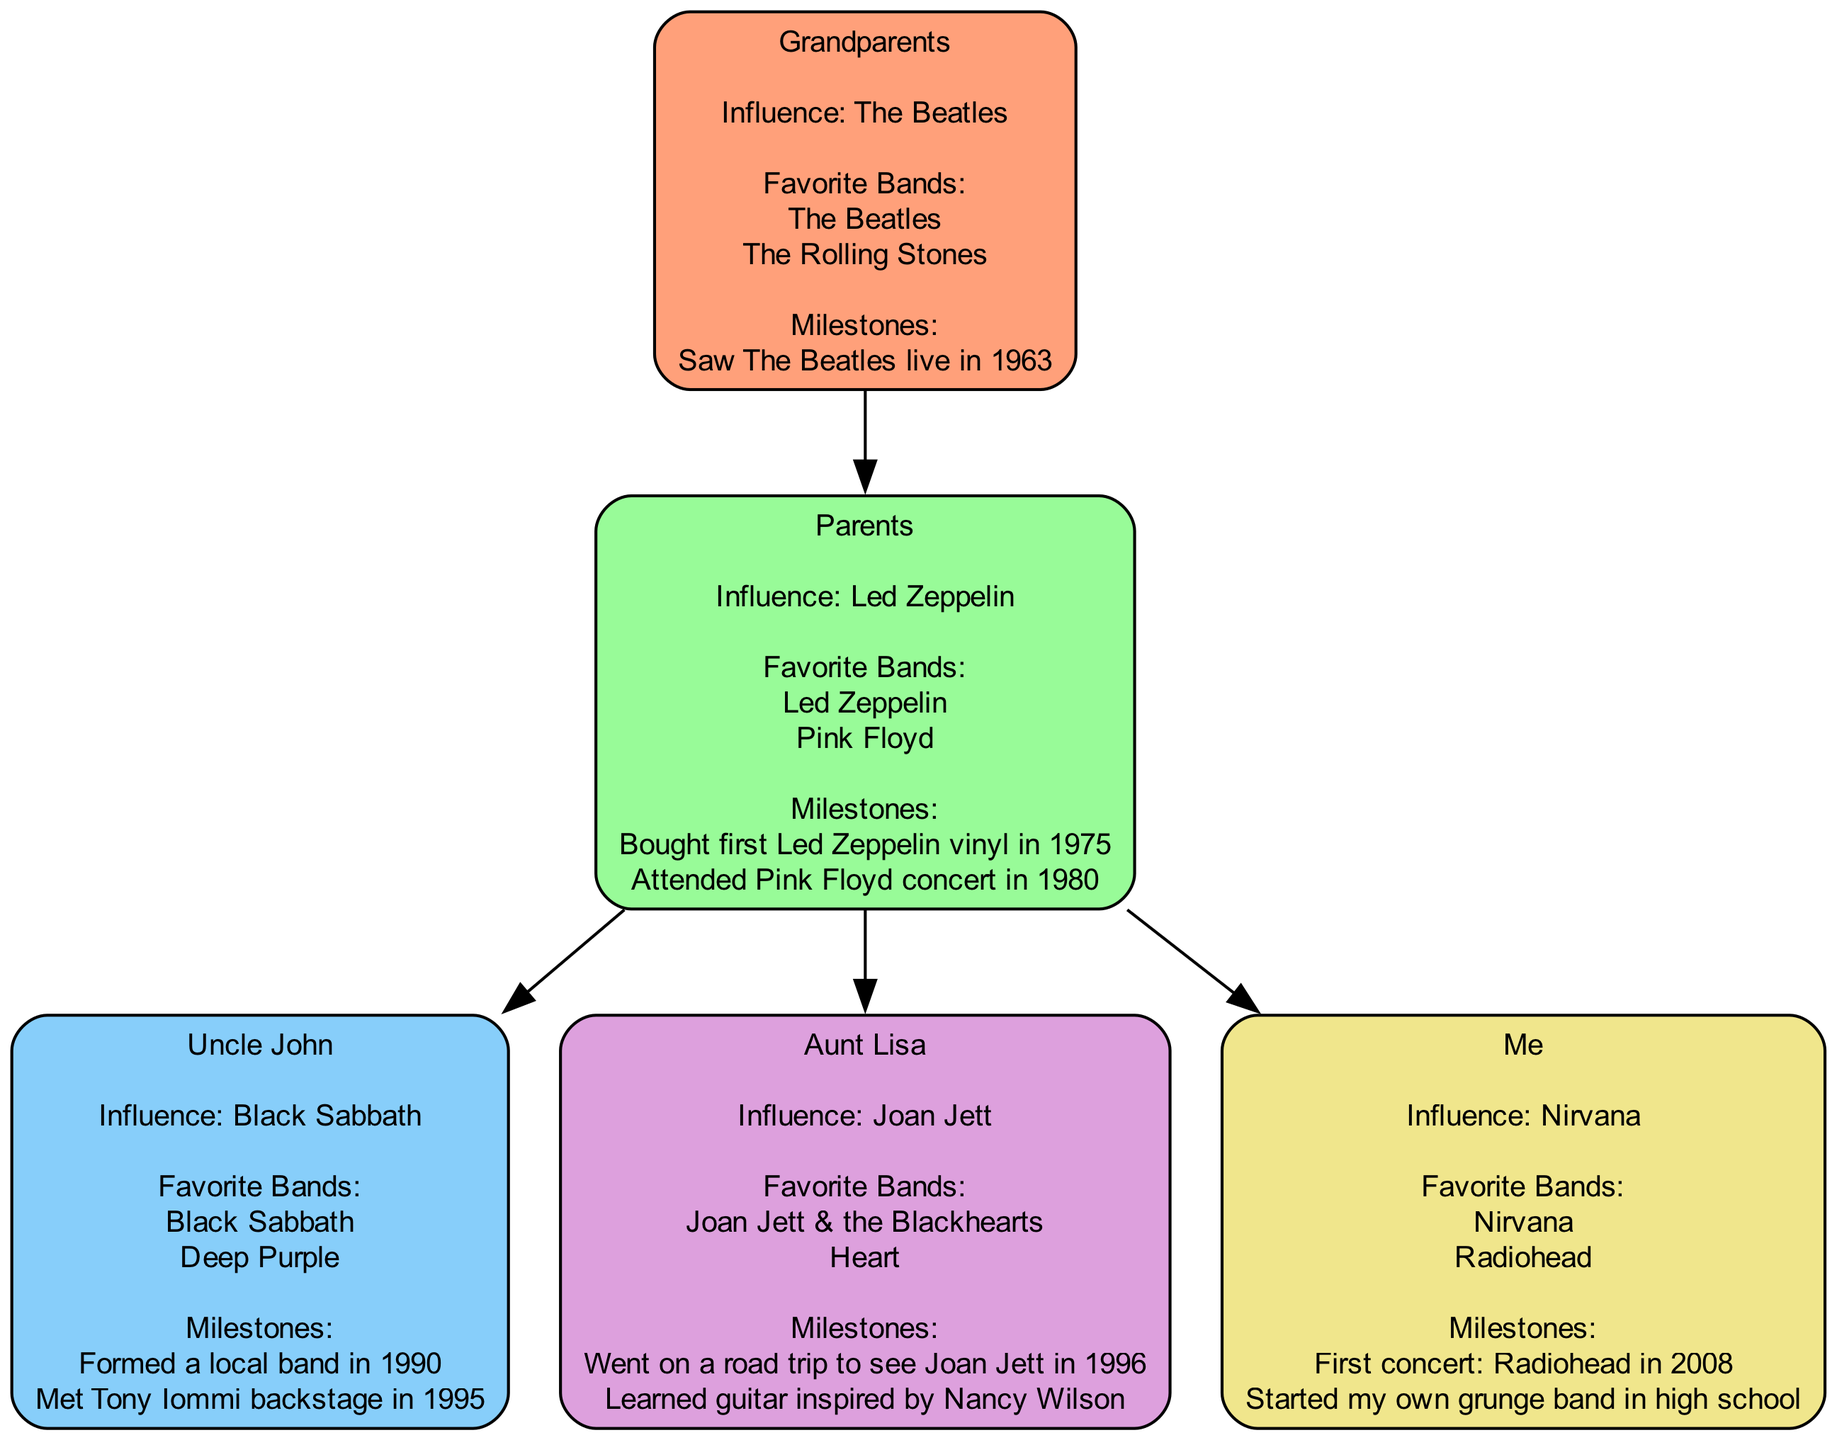What is the favorite band of Grandparents? The diagram shows that the favorite bands of the Grandparents node are listed. The Grandparents have two favorite bands: The Beatles and The Rolling Stones.
Answer: The Beatles, The Rolling Stones Who is the uncle in this family tree? In the diagram, there is a child node under Parents labeled as Uncle John. This node identifies Uncle John as the only uncle in the family tree.
Answer: Uncle John How many children do the Parents have? The Parents node has three child nodes: Uncle John, Aunt Lisa, and Me. Therefore, by counting these child nodes, the total number is three.
Answer: 3 What band influenced Me? The diagram lists the influence for Me specifically. According to that information, Me was influenced by Nirvana.
Answer: Nirvana Which year did Aunt Lisa go on a road trip? The milestones associated with Aunt Lisa include a significant event of going on a road trip to see Joan Jett in the year 1996.
Answer: 1996 Which band is identified as the influence for the Grandparents? The influence of the Grandparents is clearly labeled in the diagram as The Beatles. This can be seen directly in their node.
Answer: The Beatles What milestone is associated with the Parents in 1980? The diagram indicates that the Parents attended a Pink Floyd concert as a milestone in 1980. This detail is explicitly mentioned in their node.
Answer: Attended Pink Floyd concert in 1980 What is the relationship between Uncle John and the Parents? By analyzing the structure of the family tree, Uncle John is identified as a child of the Parents. This establishes a direct parental relationship.
Answer: Child How many favorite bands does Aunt Lisa have? Aunt Lisa has listed two favorite bands in her node within the diagram, which are Joan Jett & the Blackhearts and Heart. Therefore, the total count of favorite bands is two.
Answer: 2 